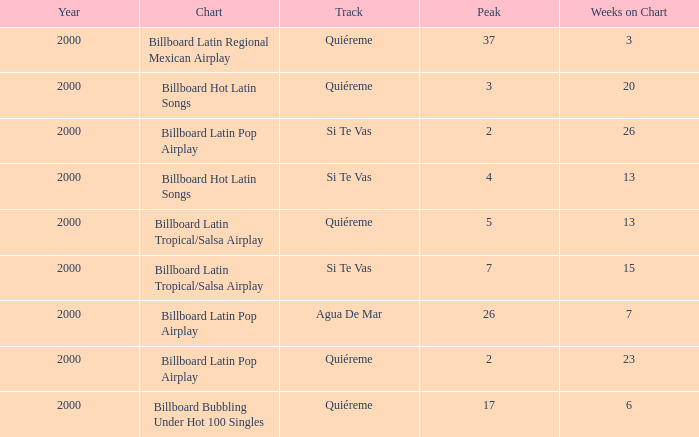Name the total number of weeks for si te vas and peak less than 7 and year less than 2000 0.0. 